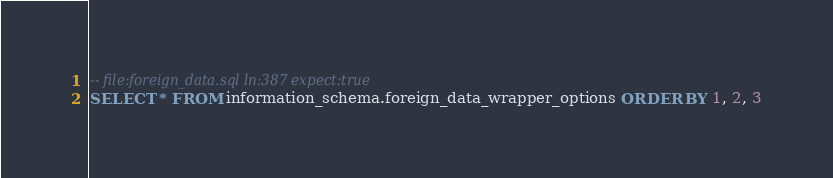<code> <loc_0><loc_0><loc_500><loc_500><_SQL_>-- file:foreign_data.sql ln:387 expect:true
SELECT * FROM information_schema.foreign_data_wrapper_options ORDER BY 1, 2, 3
</code> 